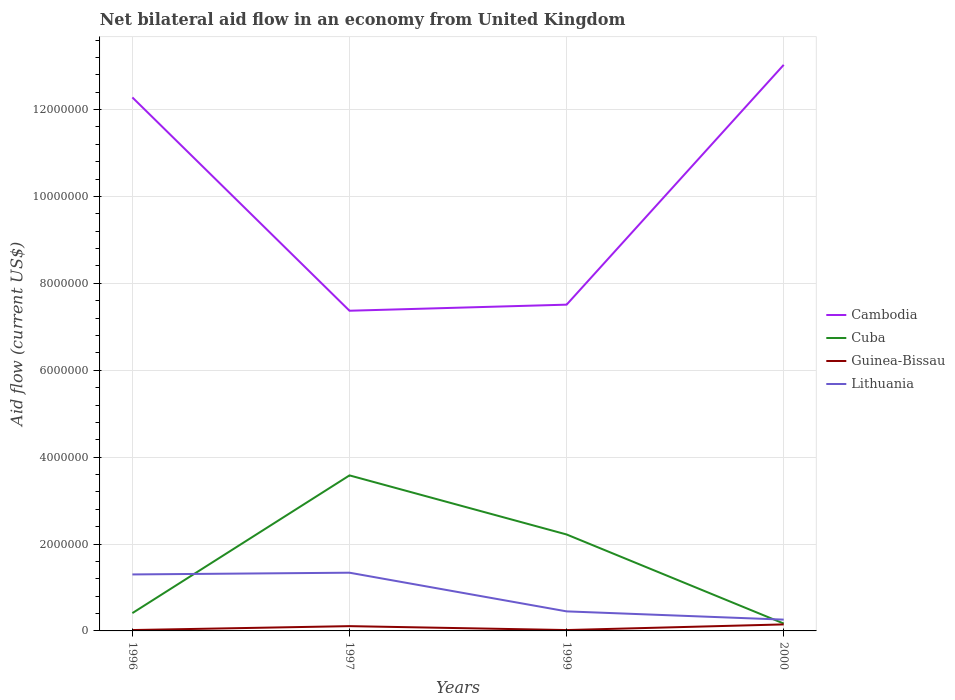How many different coloured lines are there?
Your answer should be very brief. 4. Across all years, what is the maximum net bilateral aid flow in Cambodia?
Give a very brief answer. 7.37e+06. In which year was the net bilateral aid flow in Cambodia maximum?
Give a very brief answer. 1997. What is the total net bilateral aid flow in Cambodia in the graph?
Your response must be concise. 4.91e+06. How many lines are there?
Your response must be concise. 4. How many years are there in the graph?
Offer a very short reply. 4. Does the graph contain grids?
Keep it short and to the point. Yes. How are the legend labels stacked?
Your response must be concise. Vertical. What is the title of the graph?
Give a very brief answer. Net bilateral aid flow in an economy from United Kingdom. Does "Upper middle income" appear as one of the legend labels in the graph?
Offer a terse response. No. What is the label or title of the X-axis?
Provide a succinct answer. Years. What is the Aid flow (current US$) of Cambodia in 1996?
Offer a very short reply. 1.23e+07. What is the Aid flow (current US$) in Cuba in 1996?
Make the answer very short. 4.10e+05. What is the Aid flow (current US$) in Guinea-Bissau in 1996?
Your answer should be very brief. 2.00e+04. What is the Aid flow (current US$) of Lithuania in 1996?
Offer a very short reply. 1.30e+06. What is the Aid flow (current US$) of Cambodia in 1997?
Your response must be concise. 7.37e+06. What is the Aid flow (current US$) of Cuba in 1997?
Make the answer very short. 3.58e+06. What is the Aid flow (current US$) of Guinea-Bissau in 1997?
Your response must be concise. 1.10e+05. What is the Aid flow (current US$) in Lithuania in 1997?
Make the answer very short. 1.34e+06. What is the Aid flow (current US$) in Cambodia in 1999?
Your answer should be compact. 7.51e+06. What is the Aid flow (current US$) of Cuba in 1999?
Provide a short and direct response. 2.22e+06. What is the Aid flow (current US$) of Guinea-Bissau in 1999?
Provide a succinct answer. 2.00e+04. What is the Aid flow (current US$) in Lithuania in 1999?
Your answer should be very brief. 4.50e+05. What is the Aid flow (current US$) in Cambodia in 2000?
Offer a very short reply. 1.30e+07. What is the Aid flow (current US$) in Cuba in 2000?
Keep it short and to the point. 1.70e+05. What is the Aid flow (current US$) in Guinea-Bissau in 2000?
Make the answer very short. 1.50e+05. Across all years, what is the maximum Aid flow (current US$) in Cambodia?
Your answer should be very brief. 1.30e+07. Across all years, what is the maximum Aid flow (current US$) of Cuba?
Your answer should be very brief. 3.58e+06. Across all years, what is the maximum Aid flow (current US$) of Lithuania?
Keep it short and to the point. 1.34e+06. Across all years, what is the minimum Aid flow (current US$) of Cambodia?
Give a very brief answer. 7.37e+06. Across all years, what is the minimum Aid flow (current US$) of Cuba?
Offer a very short reply. 1.70e+05. Across all years, what is the minimum Aid flow (current US$) of Lithuania?
Offer a very short reply. 2.60e+05. What is the total Aid flow (current US$) in Cambodia in the graph?
Make the answer very short. 4.02e+07. What is the total Aid flow (current US$) in Cuba in the graph?
Your response must be concise. 6.38e+06. What is the total Aid flow (current US$) of Guinea-Bissau in the graph?
Provide a short and direct response. 3.00e+05. What is the total Aid flow (current US$) in Lithuania in the graph?
Ensure brevity in your answer.  3.35e+06. What is the difference between the Aid flow (current US$) of Cambodia in 1996 and that in 1997?
Ensure brevity in your answer.  4.91e+06. What is the difference between the Aid flow (current US$) of Cuba in 1996 and that in 1997?
Give a very brief answer. -3.17e+06. What is the difference between the Aid flow (current US$) of Lithuania in 1996 and that in 1997?
Your answer should be compact. -4.00e+04. What is the difference between the Aid flow (current US$) of Cambodia in 1996 and that in 1999?
Provide a succinct answer. 4.77e+06. What is the difference between the Aid flow (current US$) in Cuba in 1996 and that in 1999?
Offer a terse response. -1.81e+06. What is the difference between the Aid flow (current US$) of Lithuania in 1996 and that in 1999?
Keep it short and to the point. 8.50e+05. What is the difference between the Aid flow (current US$) of Cambodia in 1996 and that in 2000?
Your response must be concise. -7.50e+05. What is the difference between the Aid flow (current US$) of Guinea-Bissau in 1996 and that in 2000?
Offer a terse response. -1.30e+05. What is the difference between the Aid flow (current US$) in Lithuania in 1996 and that in 2000?
Provide a short and direct response. 1.04e+06. What is the difference between the Aid flow (current US$) in Cambodia in 1997 and that in 1999?
Offer a terse response. -1.40e+05. What is the difference between the Aid flow (current US$) in Cuba in 1997 and that in 1999?
Make the answer very short. 1.36e+06. What is the difference between the Aid flow (current US$) in Guinea-Bissau in 1997 and that in 1999?
Offer a very short reply. 9.00e+04. What is the difference between the Aid flow (current US$) in Lithuania in 1997 and that in 1999?
Provide a succinct answer. 8.90e+05. What is the difference between the Aid flow (current US$) of Cambodia in 1997 and that in 2000?
Provide a short and direct response. -5.66e+06. What is the difference between the Aid flow (current US$) in Cuba in 1997 and that in 2000?
Offer a very short reply. 3.41e+06. What is the difference between the Aid flow (current US$) in Lithuania in 1997 and that in 2000?
Provide a succinct answer. 1.08e+06. What is the difference between the Aid flow (current US$) of Cambodia in 1999 and that in 2000?
Your answer should be very brief. -5.52e+06. What is the difference between the Aid flow (current US$) of Cuba in 1999 and that in 2000?
Offer a terse response. 2.05e+06. What is the difference between the Aid flow (current US$) of Guinea-Bissau in 1999 and that in 2000?
Provide a succinct answer. -1.30e+05. What is the difference between the Aid flow (current US$) in Cambodia in 1996 and the Aid flow (current US$) in Cuba in 1997?
Provide a succinct answer. 8.70e+06. What is the difference between the Aid flow (current US$) in Cambodia in 1996 and the Aid flow (current US$) in Guinea-Bissau in 1997?
Your response must be concise. 1.22e+07. What is the difference between the Aid flow (current US$) of Cambodia in 1996 and the Aid flow (current US$) of Lithuania in 1997?
Ensure brevity in your answer.  1.09e+07. What is the difference between the Aid flow (current US$) of Cuba in 1996 and the Aid flow (current US$) of Guinea-Bissau in 1997?
Offer a very short reply. 3.00e+05. What is the difference between the Aid flow (current US$) in Cuba in 1996 and the Aid flow (current US$) in Lithuania in 1997?
Make the answer very short. -9.30e+05. What is the difference between the Aid flow (current US$) of Guinea-Bissau in 1996 and the Aid flow (current US$) of Lithuania in 1997?
Your response must be concise. -1.32e+06. What is the difference between the Aid flow (current US$) of Cambodia in 1996 and the Aid flow (current US$) of Cuba in 1999?
Provide a succinct answer. 1.01e+07. What is the difference between the Aid flow (current US$) of Cambodia in 1996 and the Aid flow (current US$) of Guinea-Bissau in 1999?
Your answer should be very brief. 1.23e+07. What is the difference between the Aid flow (current US$) in Cambodia in 1996 and the Aid flow (current US$) in Lithuania in 1999?
Your answer should be very brief. 1.18e+07. What is the difference between the Aid flow (current US$) of Guinea-Bissau in 1996 and the Aid flow (current US$) of Lithuania in 1999?
Provide a succinct answer. -4.30e+05. What is the difference between the Aid flow (current US$) in Cambodia in 1996 and the Aid flow (current US$) in Cuba in 2000?
Keep it short and to the point. 1.21e+07. What is the difference between the Aid flow (current US$) of Cambodia in 1996 and the Aid flow (current US$) of Guinea-Bissau in 2000?
Provide a short and direct response. 1.21e+07. What is the difference between the Aid flow (current US$) of Cambodia in 1996 and the Aid flow (current US$) of Lithuania in 2000?
Provide a succinct answer. 1.20e+07. What is the difference between the Aid flow (current US$) of Cuba in 1996 and the Aid flow (current US$) of Guinea-Bissau in 2000?
Give a very brief answer. 2.60e+05. What is the difference between the Aid flow (current US$) of Guinea-Bissau in 1996 and the Aid flow (current US$) of Lithuania in 2000?
Give a very brief answer. -2.40e+05. What is the difference between the Aid flow (current US$) in Cambodia in 1997 and the Aid flow (current US$) in Cuba in 1999?
Give a very brief answer. 5.15e+06. What is the difference between the Aid flow (current US$) in Cambodia in 1997 and the Aid flow (current US$) in Guinea-Bissau in 1999?
Your answer should be very brief. 7.35e+06. What is the difference between the Aid flow (current US$) of Cambodia in 1997 and the Aid flow (current US$) of Lithuania in 1999?
Offer a very short reply. 6.92e+06. What is the difference between the Aid flow (current US$) of Cuba in 1997 and the Aid flow (current US$) of Guinea-Bissau in 1999?
Give a very brief answer. 3.56e+06. What is the difference between the Aid flow (current US$) of Cuba in 1997 and the Aid flow (current US$) of Lithuania in 1999?
Offer a very short reply. 3.13e+06. What is the difference between the Aid flow (current US$) in Guinea-Bissau in 1997 and the Aid flow (current US$) in Lithuania in 1999?
Your answer should be very brief. -3.40e+05. What is the difference between the Aid flow (current US$) in Cambodia in 1997 and the Aid flow (current US$) in Cuba in 2000?
Your answer should be very brief. 7.20e+06. What is the difference between the Aid flow (current US$) of Cambodia in 1997 and the Aid flow (current US$) of Guinea-Bissau in 2000?
Your response must be concise. 7.22e+06. What is the difference between the Aid flow (current US$) of Cambodia in 1997 and the Aid flow (current US$) of Lithuania in 2000?
Give a very brief answer. 7.11e+06. What is the difference between the Aid flow (current US$) of Cuba in 1997 and the Aid flow (current US$) of Guinea-Bissau in 2000?
Your answer should be very brief. 3.43e+06. What is the difference between the Aid flow (current US$) in Cuba in 1997 and the Aid flow (current US$) in Lithuania in 2000?
Give a very brief answer. 3.32e+06. What is the difference between the Aid flow (current US$) in Guinea-Bissau in 1997 and the Aid flow (current US$) in Lithuania in 2000?
Ensure brevity in your answer.  -1.50e+05. What is the difference between the Aid flow (current US$) in Cambodia in 1999 and the Aid flow (current US$) in Cuba in 2000?
Keep it short and to the point. 7.34e+06. What is the difference between the Aid flow (current US$) of Cambodia in 1999 and the Aid flow (current US$) of Guinea-Bissau in 2000?
Your response must be concise. 7.36e+06. What is the difference between the Aid flow (current US$) of Cambodia in 1999 and the Aid flow (current US$) of Lithuania in 2000?
Ensure brevity in your answer.  7.25e+06. What is the difference between the Aid flow (current US$) of Cuba in 1999 and the Aid flow (current US$) of Guinea-Bissau in 2000?
Offer a very short reply. 2.07e+06. What is the difference between the Aid flow (current US$) of Cuba in 1999 and the Aid flow (current US$) of Lithuania in 2000?
Offer a terse response. 1.96e+06. What is the difference between the Aid flow (current US$) of Guinea-Bissau in 1999 and the Aid flow (current US$) of Lithuania in 2000?
Give a very brief answer. -2.40e+05. What is the average Aid flow (current US$) in Cambodia per year?
Offer a very short reply. 1.00e+07. What is the average Aid flow (current US$) in Cuba per year?
Ensure brevity in your answer.  1.60e+06. What is the average Aid flow (current US$) of Guinea-Bissau per year?
Your answer should be compact. 7.50e+04. What is the average Aid flow (current US$) in Lithuania per year?
Your response must be concise. 8.38e+05. In the year 1996, what is the difference between the Aid flow (current US$) of Cambodia and Aid flow (current US$) of Cuba?
Offer a terse response. 1.19e+07. In the year 1996, what is the difference between the Aid flow (current US$) of Cambodia and Aid flow (current US$) of Guinea-Bissau?
Offer a terse response. 1.23e+07. In the year 1996, what is the difference between the Aid flow (current US$) of Cambodia and Aid flow (current US$) of Lithuania?
Your answer should be very brief. 1.10e+07. In the year 1996, what is the difference between the Aid flow (current US$) in Cuba and Aid flow (current US$) in Guinea-Bissau?
Your answer should be very brief. 3.90e+05. In the year 1996, what is the difference between the Aid flow (current US$) of Cuba and Aid flow (current US$) of Lithuania?
Provide a short and direct response. -8.90e+05. In the year 1996, what is the difference between the Aid flow (current US$) of Guinea-Bissau and Aid flow (current US$) of Lithuania?
Your answer should be very brief. -1.28e+06. In the year 1997, what is the difference between the Aid flow (current US$) in Cambodia and Aid flow (current US$) in Cuba?
Ensure brevity in your answer.  3.79e+06. In the year 1997, what is the difference between the Aid flow (current US$) of Cambodia and Aid flow (current US$) of Guinea-Bissau?
Keep it short and to the point. 7.26e+06. In the year 1997, what is the difference between the Aid flow (current US$) of Cambodia and Aid flow (current US$) of Lithuania?
Provide a succinct answer. 6.03e+06. In the year 1997, what is the difference between the Aid flow (current US$) of Cuba and Aid flow (current US$) of Guinea-Bissau?
Offer a very short reply. 3.47e+06. In the year 1997, what is the difference between the Aid flow (current US$) in Cuba and Aid flow (current US$) in Lithuania?
Give a very brief answer. 2.24e+06. In the year 1997, what is the difference between the Aid flow (current US$) of Guinea-Bissau and Aid flow (current US$) of Lithuania?
Keep it short and to the point. -1.23e+06. In the year 1999, what is the difference between the Aid flow (current US$) of Cambodia and Aid flow (current US$) of Cuba?
Provide a short and direct response. 5.29e+06. In the year 1999, what is the difference between the Aid flow (current US$) of Cambodia and Aid flow (current US$) of Guinea-Bissau?
Provide a succinct answer. 7.49e+06. In the year 1999, what is the difference between the Aid flow (current US$) of Cambodia and Aid flow (current US$) of Lithuania?
Provide a short and direct response. 7.06e+06. In the year 1999, what is the difference between the Aid flow (current US$) in Cuba and Aid flow (current US$) in Guinea-Bissau?
Offer a very short reply. 2.20e+06. In the year 1999, what is the difference between the Aid flow (current US$) of Cuba and Aid flow (current US$) of Lithuania?
Your answer should be very brief. 1.77e+06. In the year 1999, what is the difference between the Aid flow (current US$) in Guinea-Bissau and Aid flow (current US$) in Lithuania?
Make the answer very short. -4.30e+05. In the year 2000, what is the difference between the Aid flow (current US$) of Cambodia and Aid flow (current US$) of Cuba?
Your response must be concise. 1.29e+07. In the year 2000, what is the difference between the Aid flow (current US$) of Cambodia and Aid flow (current US$) of Guinea-Bissau?
Ensure brevity in your answer.  1.29e+07. In the year 2000, what is the difference between the Aid flow (current US$) of Cambodia and Aid flow (current US$) of Lithuania?
Provide a short and direct response. 1.28e+07. In the year 2000, what is the difference between the Aid flow (current US$) of Cuba and Aid flow (current US$) of Lithuania?
Ensure brevity in your answer.  -9.00e+04. In the year 2000, what is the difference between the Aid flow (current US$) in Guinea-Bissau and Aid flow (current US$) in Lithuania?
Keep it short and to the point. -1.10e+05. What is the ratio of the Aid flow (current US$) of Cambodia in 1996 to that in 1997?
Your answer should be very brief. 1.67. What is the ratio of the Aid flow (current US$) in Cuba in 1996 to that in 1997?
Ensure brevity in your answer.  0.11. What is the ratio of the Aid flow (current US$) in Guinea-Bissau in 1996 to that in 1997?
Your answer should be very brief. 0.18. What is the ratio of the Aid flow (current US$) in Lithuania in 1996 to that in 1997?
Give a very brief answer. 0.97. What is the ratio of the Aid flow (current US$) in Cambodia in 1996 to that in 1999?
Ensure brevity in your answer.  1.64. What is the ratio of the Aid flow (current US$) of Cuba in 1996 to that in 1999?
Your answer should be compact. 0.18. What is the ratio of the Aid flow (current US$) of Guinea-Bissau in 1996 to that in 1999?
Your answer should be compact. 1. What is the ratio of the Aid flow (current US$) of Lithuania in 1996 to that in 1999?
Your answer should be very brief. 2.89. What is the ratio of the Aid flow (current US$) of Cambodia in 1996 to that in 2000?
Ensure brevity in your answer.  0.94. What is the ratio of the Aid flow (current US$) in Cuba in 1996 to that in 2000?
Provide a short and direct response. 2.41. What is the ratio of the Aid flow (current US$) of Guinea-Bissau in 1996 to that in 2000?
Provide a succinct answer. 0.13. What is the ratio of the Aid flow (current US$) of Cambodia in 1997 to that in 1999?
Give a very brief answer. 0.98. What is the ratio of the Aid flow (current US$) of Cuba in 1997 to that in 1999?
Offer a terse response. 1.61. What is the ratio of the Aid flow (current US$) of Guinea-Bissau in 1997 to that in 1999?
Your response must be concise. 5.5. What is the ratio of the Aid flow (current US$) in Lithuania in 1997 to that in 1999?
Give a very brief answer. 2.98. What is the ratio of the Aid flow (current US$) in Cambodia in 1997 to that in 2000?
Make the answer very short. 0.57. What is the ratio of the Aid flow (current US$) of Cuba in 1997 to that in 2000?
Provide a short and direct response. 21.06. What is the ratio of the Aid flow (current US$) of Guinea-Bissau in 1997 to that in 2000?
Provide a short and direct response. 0.73. What is the ratio of the Aid flow (current US$) in Lithuania in 1997 to that in 2000?
Give a very brief answer. 5.15. What is the ratio of the Aid flow (current US$) in Cambodia in 1999 to that in 2000?
Your response must be concise. 0.58. What is the ratio of the Aid flow (current US$) of Cuba in 1999 to that in 2000?
Keep it short and to the point. 13.06. What is the ratio of the Aid flow (current US$) of Guinea-Bissau in 1999 to that in 2000?
Your answer should be compact. 0.13. What is the ratio of the Aid flow (current US$) in Lithuania in 1999 to that in 2000?
Your response must be concise. 1.73. What is the difference between the highest and the second highest Aid flow (current US$) of Cambodia?
Your response must be concise. 7.50e+05. What is the difference between the highest and the second highest Aid flow (current US$) in Cuba?
Ensure brevity in your answer.  1.36e+06. What is the difference between the highest and the second highest Aid flow (current US$) in Lithuania?
Give a very brief answer. 4.00e+04. What is the difference between the highest and the lowest Aid flow (current US$) of Cambodia?
Provide a short and direct response. 5.66e+06. What is the difference between the highest and the lowest Aid flow (current US$) in Cuba?
Offer a terse response. 3.41e+06. What is the difference between the highest and the lowest Aid flow (current US$) in Lithuania?
Make the answer very short. 1.08e+06. 